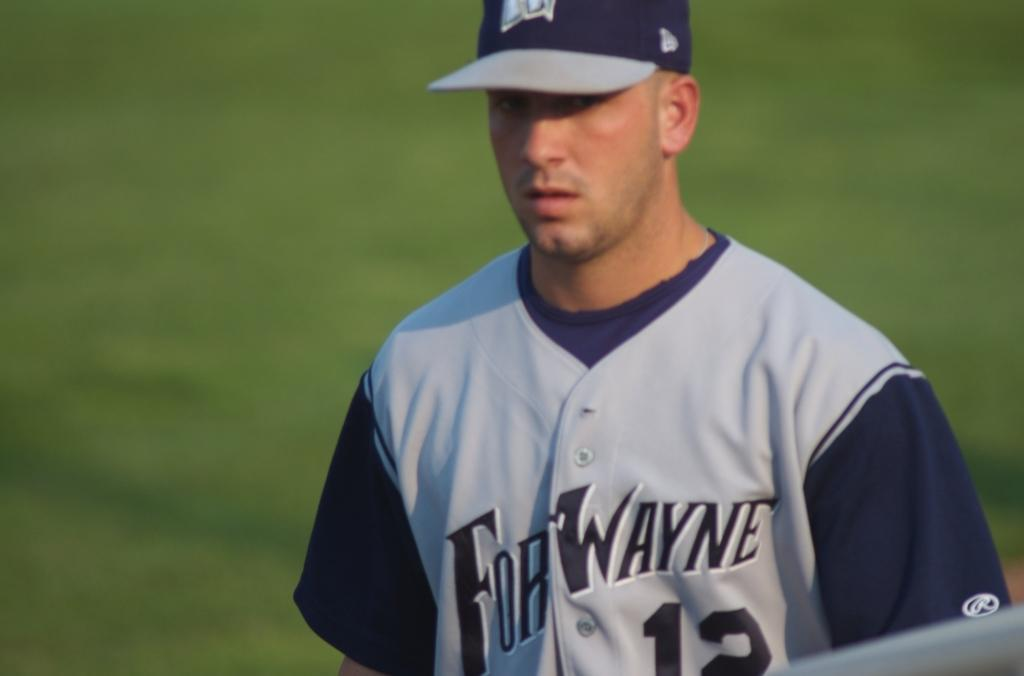<image>
Provide a brief description of the given image. A baseball player for the Fort Wayne team wears the number 12 jersey. 